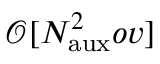<formula> <loc_0><loc_0><loc_500><loc_500>\mathcal { O } [ N _ { a u x } ^ { 2 } o v ]</formula> 